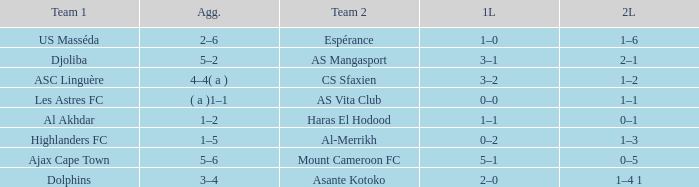What is the 2nd leg of team 1 Dolphins? 1–4 1. 